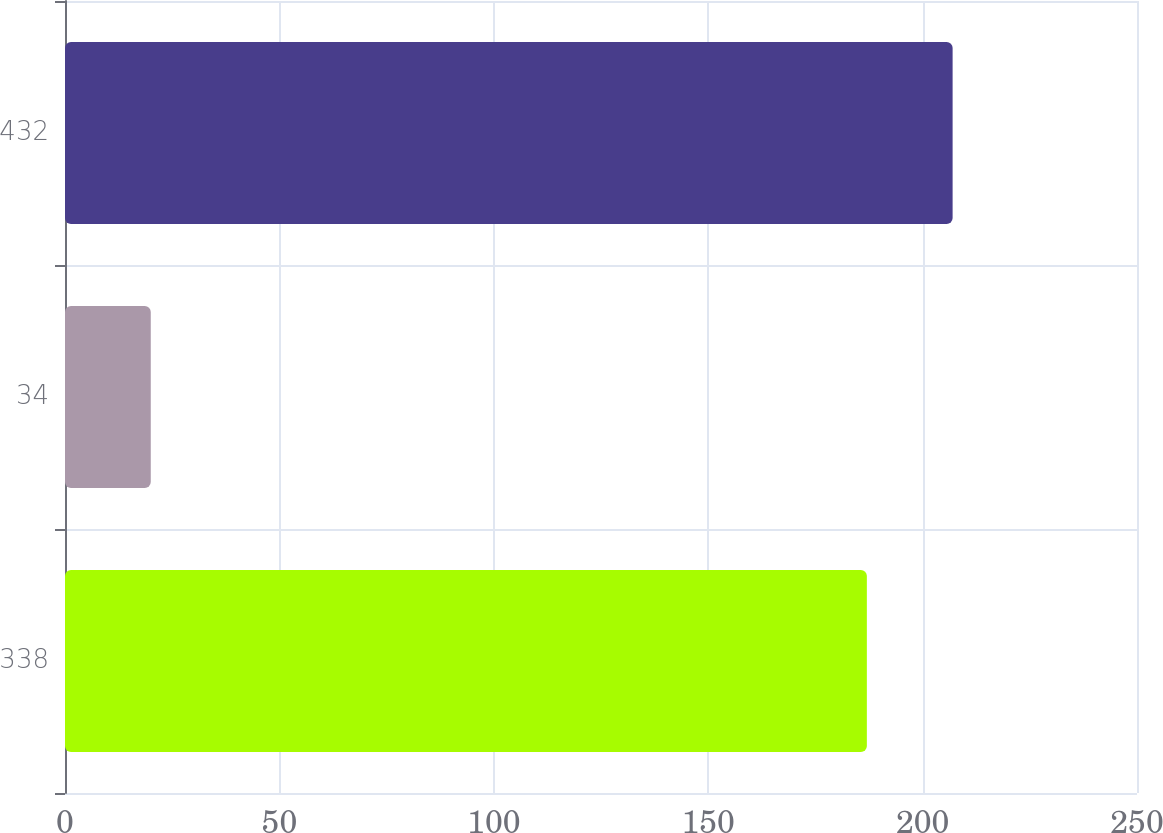Convert chart to OTSL. <chart><loc_0><loc_0><loc_500><loc_500><bar_chart><fcel>338<fcel>34<fcel>432<nl><fcel>187<fcel>20<fcel>207<nl></chart> 